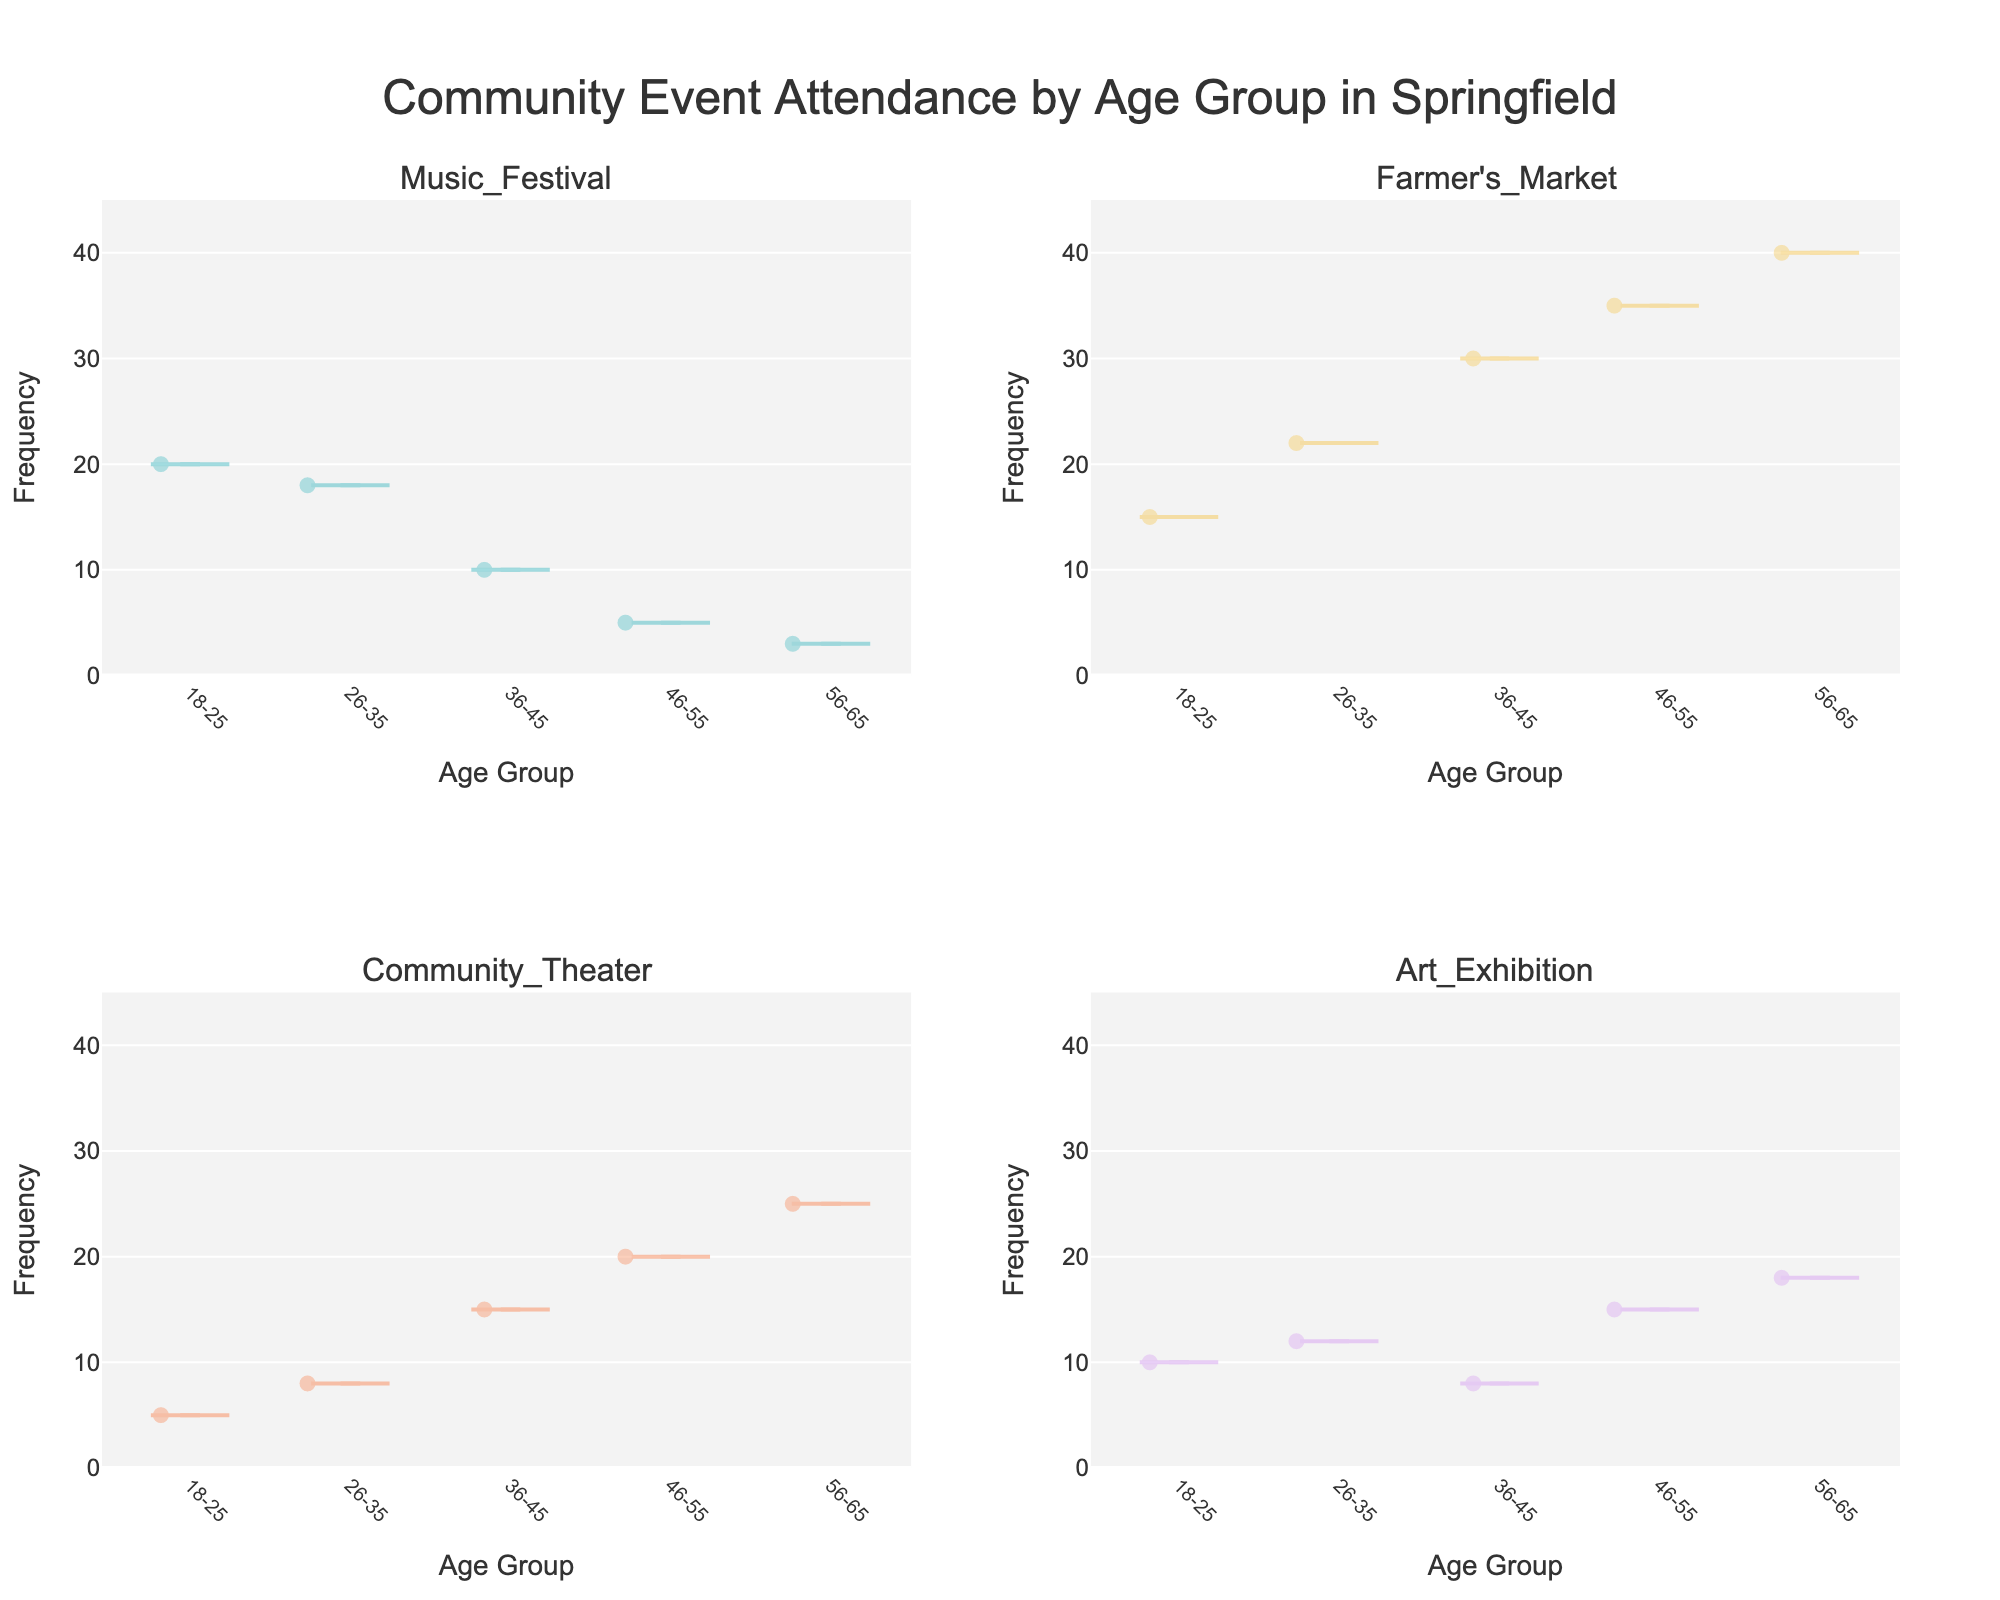What's the title of the figure? The title can be found at the top of the figure.
Answer: Community Event Attendance by Age Group in Springfield Which age group attends the Farmer's Market most frequently? By looking at the violin plot for the Farmer's Market, the 56-65 age group has the highest frequency, reaching up to 40.
Answer: 56-65 age group Between the 18-25 and 26-35 age groups, which one attends the Community Theater more often? Comparing the height of the violin plots for Community Theater, the 26-35 age group has higher frequency values than the 18-25 age group.
Answer: 26-35 age group What age group has the highest average attendance for Art Exhibitions? Looking at the distribution of the violin plot for Art Exhibitions, the 56-65 age group seems to have the highest values, indicating the highest average attendance.
Answer: 56-65 age group How does the attendance of Music Festivals compare between the 18-25 and 46-55 age groups? The violin plot for Music Festivals shows that the 18-25 age group has higher and denser frequency values compared to the 46-55 age group.
Answer: 18-25 age group Which event type shows the broadest range of attendance frequencies across all age groups? The violin plot with the widest spread from top to bottom indicates the broadest range. The Farmer's Market plot spans from low to high frequencies for all age groups.
Answer: Farmer's Market For the 36-45 age group, which event has the lowest frequency of attendance? Looking at the frequencies listed under each event for the 36-45 age group, Art Exhibitions have the lowest attendance frequency of 8.
Answer: Art Exhibition Which age group predominantly attends Community Theater? The violin plot for Community Theater shows the 56-65 age group having the highest frequency of attendance.
Answer: 56-65 age group On average, do older age groups attend Art Exhibitions more frequently than younger age groups? By comparing the average values visually within each violin plot for Art Exhibitions, older age groups (46-55 and 56-65) seem to have higher attendance frequencies compared to younger groups.
Answer: Yes What's the general trend in event attendance as age increases? Observing all violin plots for different events, the trend is that frequencies shift from social events (like Music Festivals) to local and cultural engagements (like Farmer's Markets and Community Theater) as age increases.
Answer: From social to local and cultural events 